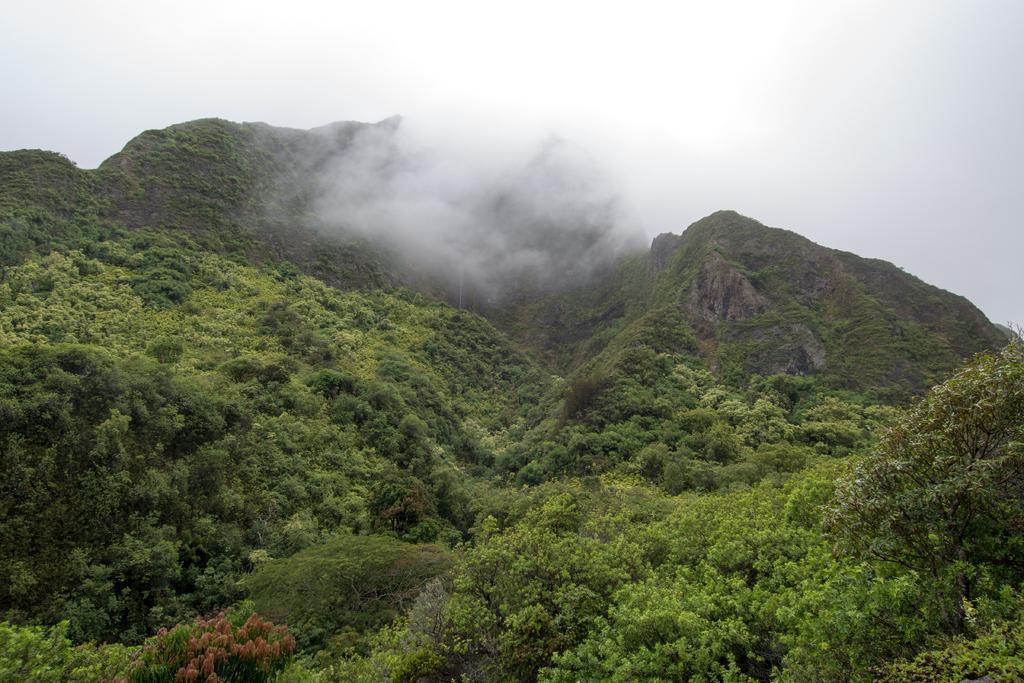In one or two sentences, can you explain what this image depicts? In the image there are many hills with trees and plants all over the place and above its sky with clouds. 